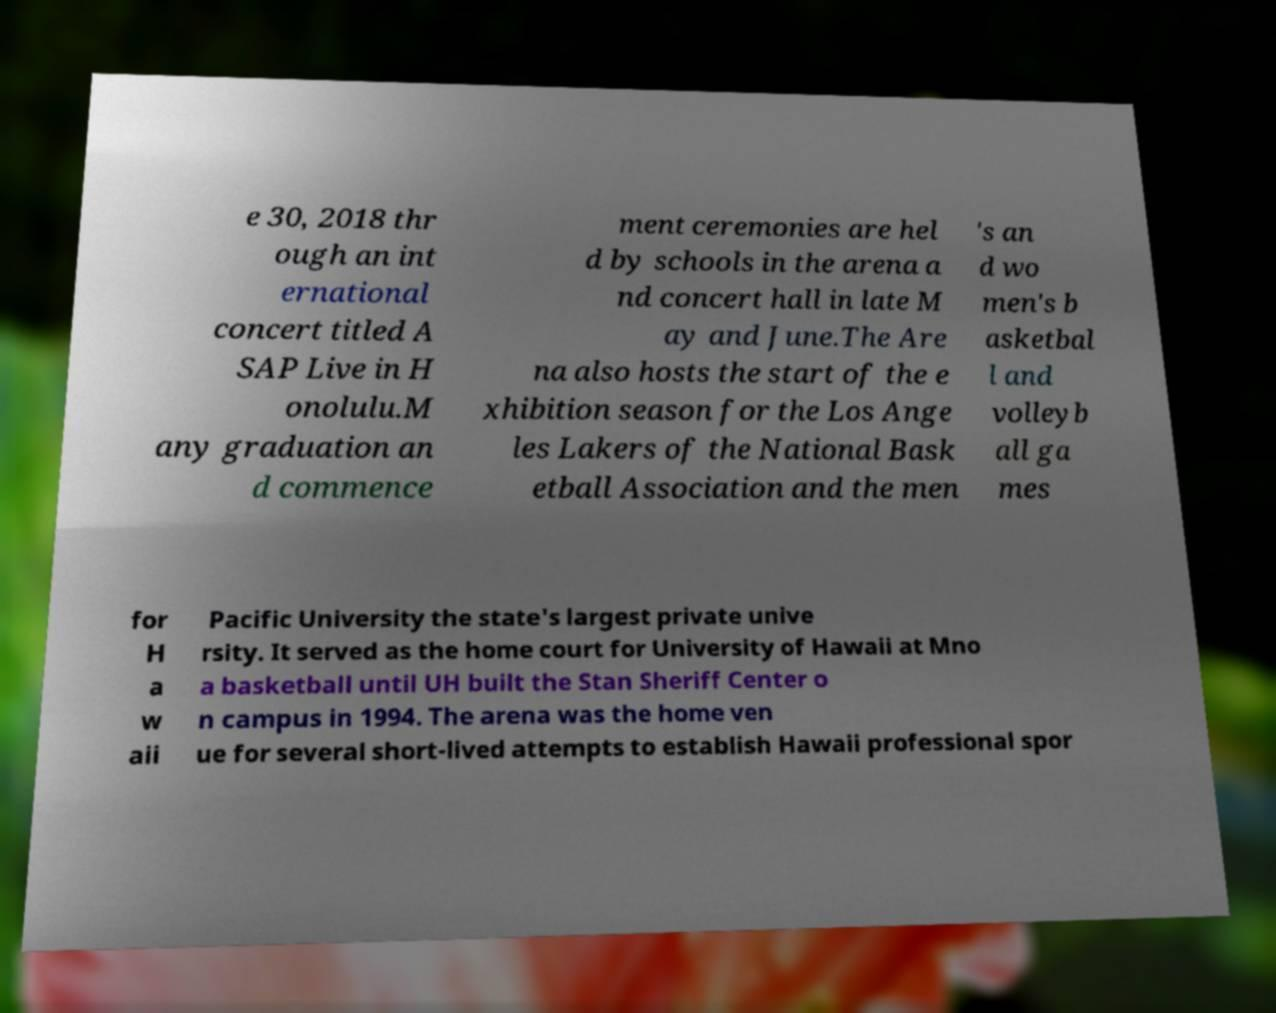Can you accurately transcribe the text from the provided image for me? e 30, 2018 thr ough an int ernational concert titled A SAP Live in H onolulu.M any graduation an d commence ment ceremonies are hel d by schools in the arena a nd concert hall in late M ay and June.The Are na also hosts the start of the e xhibition season for the Los Ange les Lakers of the National Bask etball Association and the men 's an d wo men's b asketbal l and volleyb all ga mes for H a w aii Pacific University the state's largest private unive rsity. It served as the home court for University of Hawaii at Mno a basketball until UH built the Stan Sheriff Center o n campus in 1994. The arena was the home ven ue for several short-lived attempts to establish Hawaii professional spor 